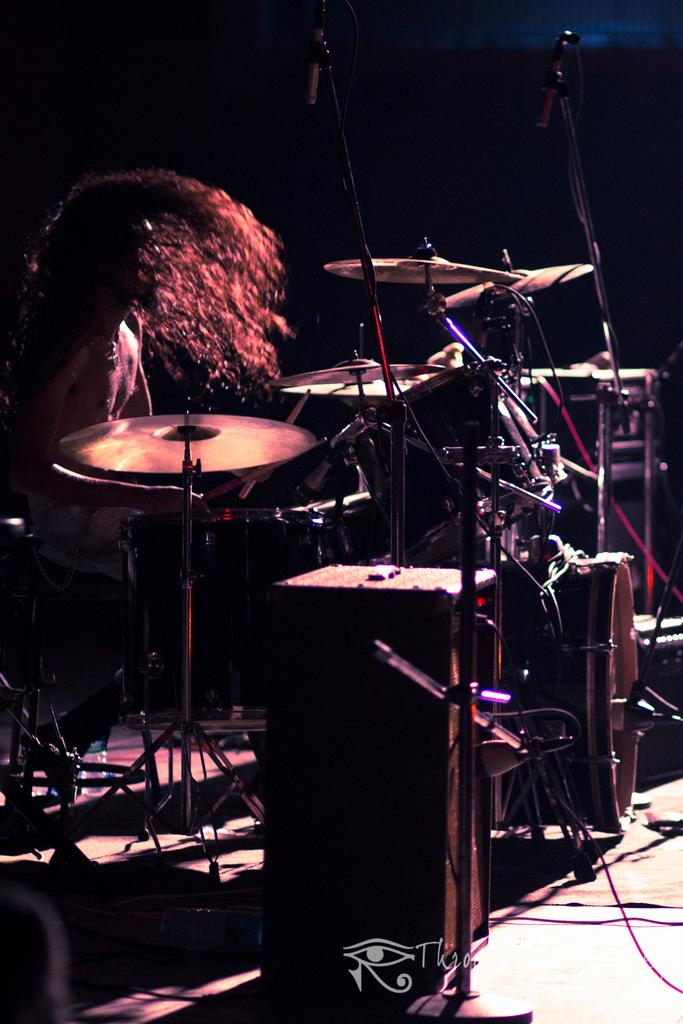What is the main subject of the image? There is a person sitting in the center of the image. What is in front of the person? There are microphones in front of the person. What are the microphones used for? The microphones are for musical instruments. Are there any other objects in front of the person? Yes, there are a few other objects in front of the person. What is the person's profit from the trade in the image? There is no mention of trade or profit in the image, as it features a person sitting with microphones for musical instruments. 